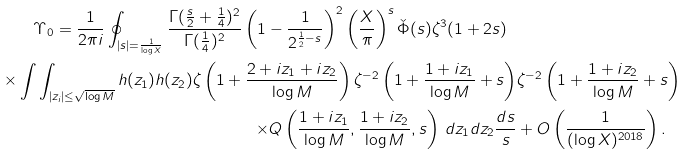<formula> <loc_0><loc_0><loc_500><loc_500>\Upsilon _ { 0 } = \frac { 1 } { 2 \pi i } \oint _ { | s | = \frac { 1 } { \log X } } \frac { \Gamma ( \frac { s } { 2 } + \frac { 1 } { 4 } ) ^ { 2 } } { \Gamma ( \frac { 1 } { 4 } ) ^ { 2 } } \left ( 1 - \frac { 1 } { 2 ^ { \frac { 1 } { 2 } - s } } \right ) ^ { 2 } \left ( \frac { X } { \pi } \right ) ^ { s } \check { \Phi } ( s ) \zeta ^ { 3 } ( 1 + 2 s ) \ & \\ \times \int \int _ { | z _ { i } | \leq \sqrt { \log M } } h ( z _ { 1 } ) h ( z _ { 2 } ) \zeta \left ( 1 + \frac { 2 + i z _ { 1 } + i z _ { 2 } } { \log M } \right ) \zeta ^ { - 2 } \left ( 1 + \frac { 1 + i z _ { 1 } } { \log M } + s \right ) & \zeta ^ { - 2 } \left ( 1 + \frac { 1 + i z _ { 2 } } { \log M } + s \right ) \\ \times Q \left ( \frac { 1 + i z _ { 1 } } { \log M } , \frac { 1 + i z _ { 2 } } { \log M } , s \right ) \, d z _ { 1 } d z _ { 2 } \frac { d s } { s } & + O \left ( \frac { 1 } { ( \log X ) ^ { 2 0 1 8 } } \right ) .</formula> 